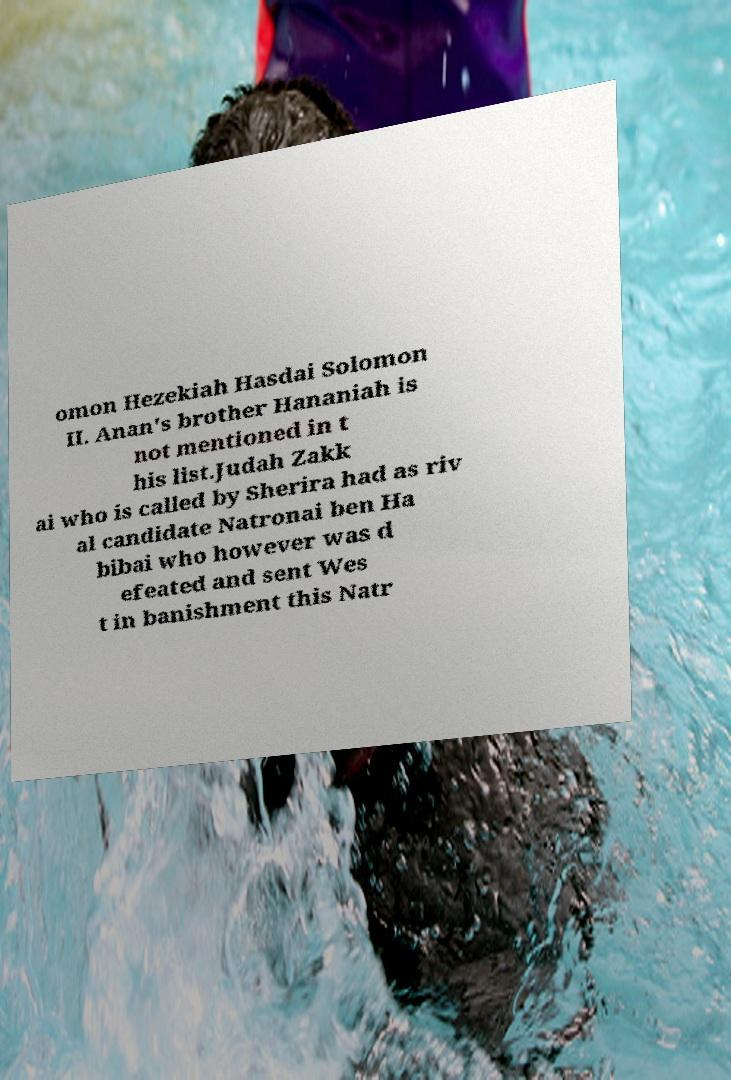Could you assist in decoding the text presented in this image and type it out clearly? omon Hezekiah Hasdai Solomon II. Anan's brother Hananiah is not mentioned in t his list.Judah Zakk ai who is called by Sherira had as riv al candidate Natronai ben Ha bibai who however was d efeated and sent Wes t in banishment this Natr 